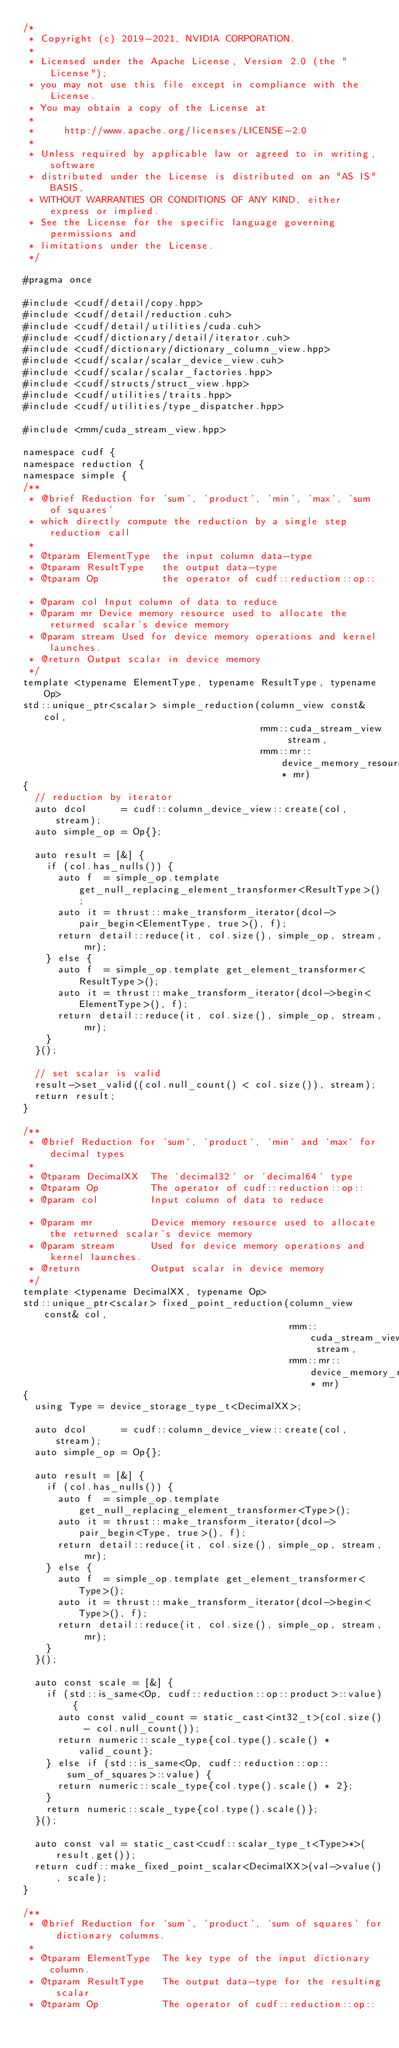Convert code to text. <code><loc_0><loc_0><loc_500><loc_500><_Cuda_>/*
 * Copyright (c) 2019-2021, NVIDIA CORPORATION.
 *
 * Licensed under the Apache License, Version 2.0 (the "License");
 * you may not use this file except in compliance with the License.
 * You may obtain a copy of the License at
 *
 *     http://www.apache.org/licenses/LICENSE-2.0
 *
 * Unless required by applicable law or agreed to in writing, software
 * distributed under the License is distributed on an "AS IS" BASIS,
 * WITHOUT WARRANTIES OR CONDITIONS OF ANY KIND, either express or implied.
 * See the License for the specific language governing permissions and
 * limitations under the License.
 */

#pragma once

#include <cudf/detail/copy.hpp>
#include <cudf/detail/reduction.cuh>
#include <cudf/detail/utilities/cuda.cuh>
#include <cudf/dictionary/detail/iterator.cuh>
#include <cudf/dictionary/dictionary_column_view.hpp>
#include <cudf/scalar/scalar_device_view.cuh>
#include <cudf/scalar/scalar_factories.hpp>
#include <cudf/structs/struct_view.hpp>
#include <cudf/utilities/traits.hpp>
#include <cudf/utilities/type_dispatcher.hpp>

#include <rmm/cuda_stream_view.hpp>

namespace cudf {
namespace reduction {
namespace simple {
/**
 * @brief Reduction for 'sum', 'product', 'min', 'max', 'sum of squares'
 * which directly compute the reduction by a single step reduction call
 *
 * @tparam ElementType  the input column data-type
 * @tparam ResultType   the output data-type
 * @tparam Op           the operator of cudf::reduction::op::

 * @param col Input column of data to reduce
 * @param mr Device memory resource used to allocate the returned scalar's device memory
 * @param stream Used for device memory operations and kernel launches.
 * @return Output scalar in device memory
 */
template <typename ElementType, typename ResultType, typename Op>
std::unique_ptr<scalar> simple_reduction(column_view const& col,
                                         rmm::cuda_stream_view stream,
                                         rmm::mr::device_memory_resource* mr)
{
  // reduction by iterator
  auto dcol      = cudf::column_device_view::create(col, stream);
  auto simple_op = Op{};

  auto result = [&] {
    if (col.has_nulls()) {
      auto f  = simple_op.template get_null_replacing_element_transformer<ResultType>();
      auto it = thrust::make_transform_iterator(dcol->pair_begin<ElementType, true>(), f);
      return detail::reduce(it, col.size(), simple_op, stream, mr);
    } else {
      auto f  = simple_op.template get_element_transformer<ResultType>();
      auto it = thrust::make_transform_iterator(dcol->begin<ElementType>(), f);
      return detail::reduce(it, col.size(), simple_op, stream, mr);
    }
  }();

  // set scalar is valid
  result->set_valid((col.null_count() < col.size()), stream);
  return result;
}

/**
 * @brief Reduction for `sum`, `product`, `min` and `max` for decimal types
 *
 * @tparam DecimalXX  The `decimal32` or `decimal64` type
 * @tparam Op         The operator of cudf::reduction::op::
 * @param col         Input column of data to reduce

 * @param mr          Device memory resource used to allocate the returned scalar's device memory
 * @param stream      Used for device memory operations and kernel launches.
 * @return            Output scalar in device memory
 */
template <typename DecimalXX, typename Op>
std::unique_ptr<scalar> fixed_point_reduction(column_view const& col,
                                              rmm::cuda_stream_view stream,
                                              rmm::mr::device_memory_resource* mr)
{
  using Type = device_storage_type_t<DecimalXX>;

  auto dcol      = cudf::column_device_view::create(col, stream);
  auto simple_op = Op{};

  auto result = [&] {
    if (col.has_nulls()) {
      auto f  = simple_op.template get_null_replacing_element_transformer<Type>();
      auto it = thrust::make_transform_iterator(dcol->pair_begin<Type, true>(), f);
      return detail::reduce(it, col.size(), simple_op, stream, mr);
    } else {
      auto f  = simple_op.template get_element_transformer<Type>();
      auto it = thrust::make_transform_iterator(dcol->begin<Type>(), f);
      return detail::reduce(it, col.size(), simple_op, stream, mr);
    }
  }();

  auto const scale = [&] {
    if (std::is_same<Op, cudf::reduction::op::product>::value) {
      auto const valid_count = static_cast<int32_t>(col.size() - col.null_count());
      return numeric::scale_type{col.type().scale() * valid_count};
    } else if (std::is_same<Op, cudf::reduction::op::sum_of_squares>::value) {
      return numeric::scale_type{col.type().scale() * 2};
    }
    return numeric::scale_type{col.type().scale()};
  }();

  auto const val = static_cast<cudf::scalar_type_t<Type>*>(result.get());
  return cudf::make_fixed_point_scalar<DecimalXX>(val->value(), scale);
}

/**
 * @brief Reduction for 'sum', 'product', 'sum of squares' for dictionary columns.
 *
 * @tparam ElementType  The key type of the input dictionary column.
 * @tparam ResultType   The output data-type for the resulting scalar
 * @tparam Op           The operator of cudf::reduction::op::
</code> 